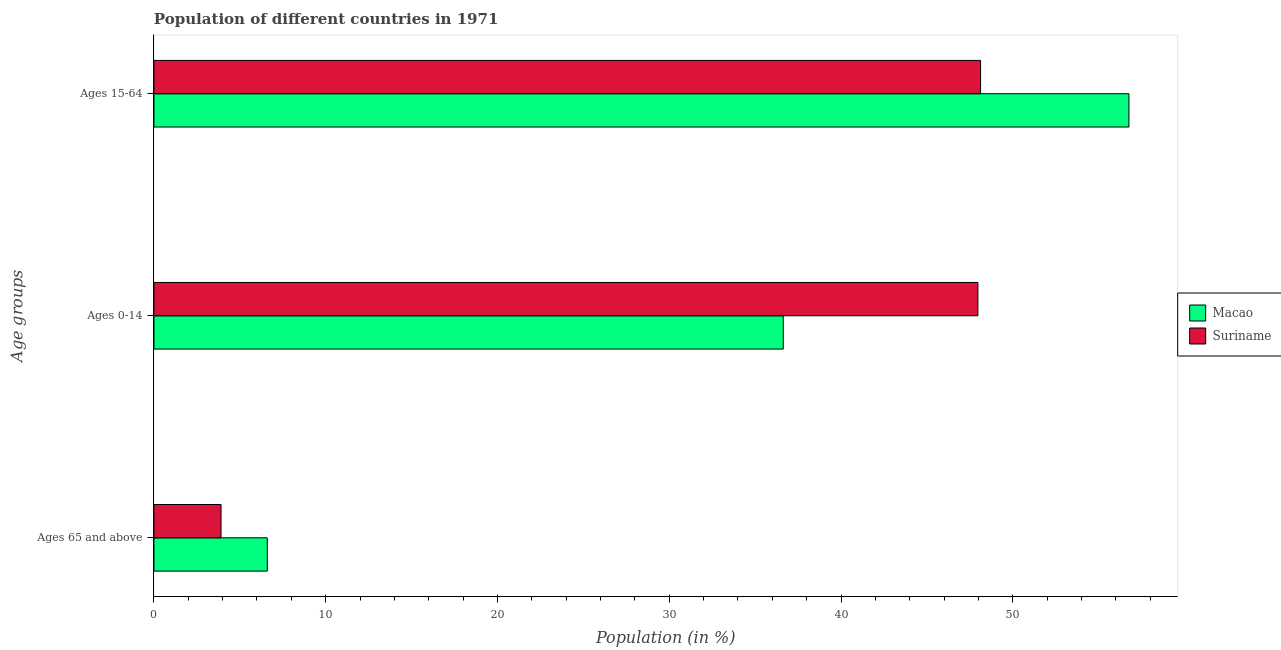How many groups of bars are there?
Offer a terse response. 3. Are the number of bars per tick equal to the number of legend labels?
Offer a very short reply. Yes. How many bars are there on the 1st tick from the top?
Your response must be concise. 2. How many bars are there on the 1st tick from the bottom?
Give a very brief answer. 2. What is the label of the 2nd group of bars from the top?
Give a very brief answer. Ages 0-14. What is the percentage of population within the age-group 0-14 in Suriname?
Your answer should be very brief. 47.97. Across all countries, what is the maximum percentage of population within the age-group of 65 and above?
Your response must be concise. 6.6. Across all countries, what is the minimum percentage of population within the age-group 0-14?
Offer a very short reply. 36.64. In which country was the percentage of population within the age-group of 65 and above maximum?
Keep it short and to the point. Macao. In which country was the percentage of population within the age-group 15-64 minimum?
Your answer should be compact. Suriname. What is the total percentage of population within the age-group 15-64 in the graph?
Your answer should be compact. 104.88. What is the difference between the percentage of population within the age-group 15-64 in Suriname and that in Macao?
Ensure brevity in your answer.  -8.64. What is the difference between the percentage of population within the age-group of 65 and above in Suriname and the percentage of population within the age-group 0-14 in Macao?
Provide a succinct answer. -32.73. What is the average percentage of population within the age-group of 65 and above per country?
Offer a terse response. 5.25. What is the difference between the percentage of population within the age-group of 65 and above and percentage of population within the age-group 0-14 in Macao?
Keep it short and to the point. -30.04. What is the ratio of the percentage of population within the age-group 15-64 in Suriname to that in Macao?
Make the answer very short. 0.85. Is the percentage of population within the age-group of 65 and above in Suriname less than that in Macao?
Your answer should be very brief. Yes. What is the difference between the highest and the second highest percentage of population within the age-group 0-14?
Your response must be concise. 11.33. What is the difference between the highest and the lowest percentage of population within the age-group 15-64?
Provide a short and direct response. 8.64. In how many countries, is the percentage of population within the age-group of 65 and above greater than the average percentage of population within the age-group of 65 and above taken over all countries?
Offer a terse response. 1. Is the sum of the percentage of population within the age-group 0-14 in Macao and Suriname greater than the maximum percentage of population within the age-group of 65 and above across all countries?
Provide a short and direct response. Yes. What does the 2nd bar from the top in Ages 0-14 represents?
Your answer should be very brief. Macao. What does the 1st bar from the bottom in Ages 15-64 represents?
Offer a very short reply. Macao. Are the values on the major ticks of X-axis written in scientific E-notation?
Give a very brief answer. No. Does the graph contain grids?
Your answer should be very brief. No. Where does the legend appear in the graph?
Your answer should be compact. Center right. How are the legend labels stacked?
Offer a very short reply. Vertical. What is the title of the graph?
Provide a succinct answer. Population of different countries in 1971. Does "Bhutan" appear as one of the legend labels in the graph?
Provide a short and direct response. No. What is the label or title of the Y-axis?
Provide a short and direct response. Age groups. What is the Population (in %) of Macao in Ages 65 and above?
Give a very brief answer. 6.6. What is the Population (in %) in Suriname in Ages 65 and above?
Keep it short and to the point. 3.91. What is the Population (in %) of Macao in Ages 0-14?
Your response must be concise. 36.64. What is the Population (in %) in Suriname in Ages 0-14?
Your answer should be compact. 47.97. What is the Population (in %) of Macao in Ages 15-64?
Your answer should be compact. 56.76. What is the Population (in %) of Suriname in Ages 15-64?
Your answer should be very brief. 48.12. Across all Age groups, what is the maximum Population (in %) of Macao?
Give a very brief answer. 56.76. Across all Age groups, what is the maximum Population (in %) of Suriname?
Make the answer very short. 48.12. Across all Age groups, what is the minimum Population (in %) in Macao?
Your answer should be very brief. 6.6. Across all Age groups, what is the minimum Population (in %) in Suriname?
Provide a succinct answer. 3.91. What is the total Population (in %) of Macao in the graph?
Your response must be concise. 100. What is the difference between the Population (in %) in Macao in Ages 65 and above and that in Ages 0-14?
Give a very brief answer. -30.04. What is the difference between the Population (in %) of Suriname in Ages 65 and above and that in Ages 0-14?
Provide a succinct answer. -44.06. What is the difference between the Population (in %) of Macao in Ages 65 and above and that in Ages 15-64?
Ensure brevity in your answer.  -50.16. What is the difference between the Population (in %) of Suriname in Ages 65 and above and that in Ages 15-64?
Make the answer very short. -44.22. What is the difference between the Population (in %) in Macao in Ages 0-14 and that in Ages 15-64?
Offer a very short reply. -20.12. What is the difference between the Population (in %) in Suriname in Ages 0-14 and that in Ages 15-64?
Make the answer very short. -0.15. What is the difference between the Population (in %) of Macao in Ages 65 and above and the Population (in %) of Suriname in Ages 0-14?
Your answer should be very brief. -41.37. What is the difference between the Population (in %) in Macao in Ages 65 and above and the Population (in %) in Suriname in Ages 15-64?
Offer a very short reply. -41.52. What is the difference between the Population (in %) of Macao in Ages 0-14 and the Population (in %) of Suriname in Ages 15-64?
Provide a short and direct response. -11.48. What is the average Population (in %) in Macao per Age groups?
Your answer should be very brief. 33.33. What is the average Population (in %) in Suriname per Age groups?
Your answer should be compact. 33.33. What is the difference between the Population (in %) in Macao and Population (in %) in Suriname in Ages 65 and above?
Provide a succinct answer. 2.69. What is the difference between the Population (in %) of Macao and Population (in %) of Suriname in Ages 0-14?
Ensure brevity in your answer.  -11.33. What is the difference between the Population (in %) in Macao and Population (in %) in Suriname in Ages 15-64?
Provide a succinct answer. 8.64. What is the ratio of the Population (in %) in Macao in Ages 65 and above to that in Ages 0-14?
Your answer should be very brief. 0.18. What is the ratio of the Population (in %) in Suriname in Ages 65 and above to that in Ages 0-14?
Provide a succinct answer. 0.08. What is the ratio of the Population (in %) in Macao in Ages 65 and above to that in Ages 15-64?
Keep it short and to the point. 0.12. What is the ratio of the Population (in %) in Suriname in Ages 65 and above to that in Ages 15-64?
Keep it short and to the point. 0.08. What is the ratio of the Population (in %) of Macao in Ages 0-14 to that in Ages 15-64?
Offer a terse response. 0.65. What is the ratio of the Population (in %) of Suriname in Ages 0-14 to that in Ages 15-64?
Keep it short and to the point. 1. What is the difference between the highest and the second highest Population (in %) in Macao?
Give a very brief answer. 20.12. What is the difference between the highest and the second highest Population (in %) in Suriname?
Your answer should be very brief. 0.15. What is the difference between the highest and the lowest Population (in %) in Macao?
Provide a succinct answer. 50.16. What is the difference between the highest and the lowest Population (in %) of Suriname?
Your answer should be very brief. 44.22. 